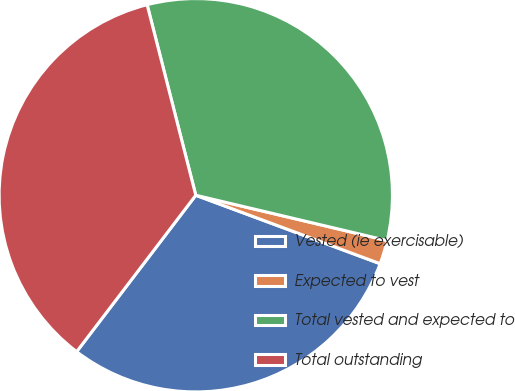Convert chart to OTSL. <chart><loc_0><loc_0><loc_500><loc_500><pie_chart><fcel>Vested (ie exercisable)<fcel>Expected to vest<fcel>Total vested and expected to<fcel>Total outstanding<nl><fcel>29.7%<fcel>1.96%<fcel>32.68%<fcel>35.66%<nl></chart> 